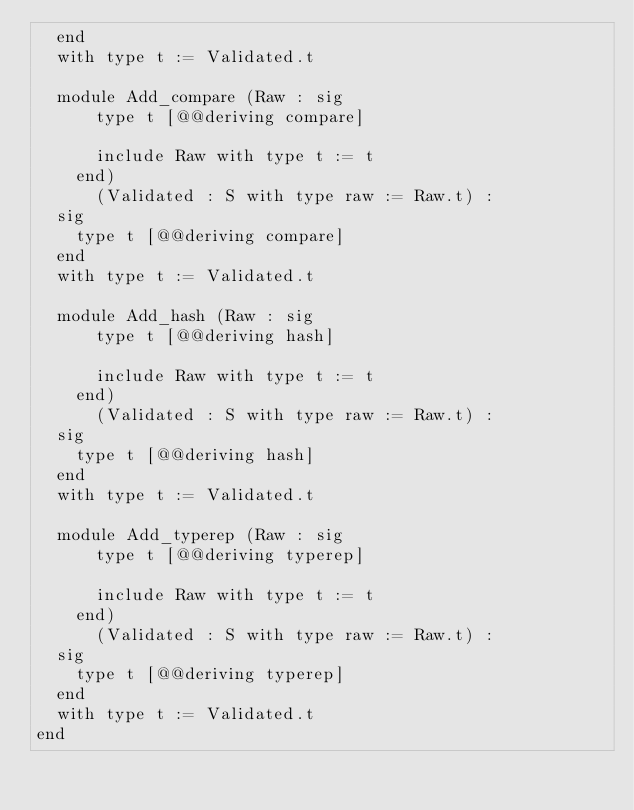<code> <loc_0><loc_0><loc_500><loc_500><_OCaml_>  end
  with type t := Validated.t

  module Add_compare (Raw : sig
      type t [@@deriving compare]

      include Raw with type t := t
    end)
      (Validated : S with type raw := Raw.t) :
  sig
    type t [@@deriving compare]
  end
  with type t := Validated.t

  module Add_hash (Raw : sig
      type t [@@deriving hash]

      include Raw with type t := t
    end)
      (Validated : S with type raw := Raw.t) :
  sig
    type t [@@deriving hash]
  end
  with type t := Validated.t

  module Add_typerep (Raw : sig
      type t [@@deriving typerep]

      include Raw with type t := t
    end)
      (Validated : S with type raw := Raw.t) :
  sig
    type t [@@deriving typerep]
  end
  with type t := Validated.t
end
</code> 